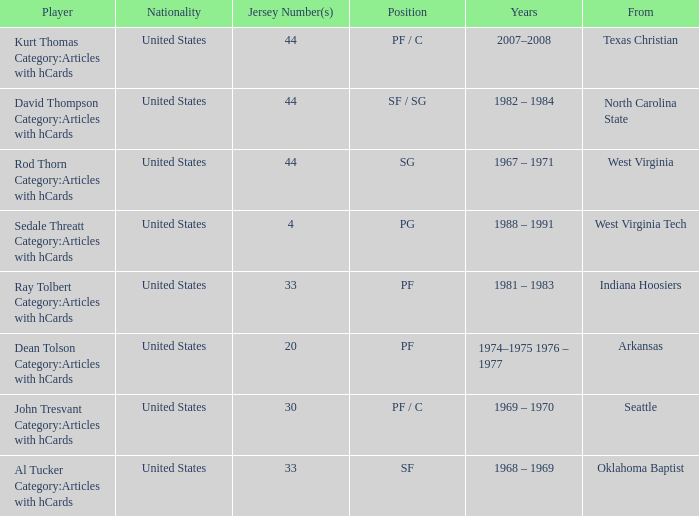In what years did the power forward with the jersey number 33 take part in games? 1981 – 1983. 